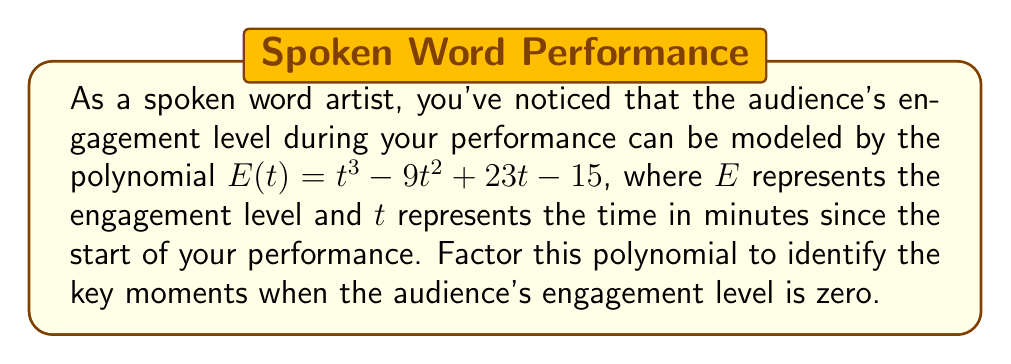Can you answer this question? To factor this cubic polynomial, we'll follow these steps:

1) First, let's check if there's a rational root. We can use the rational root theorem to find potential roots. The factors of the constant term (15) are ±1, ±3, ±5, ±15.

2) Testing these values, we find that $t = 1$ is a root of the polynomial.

3) We can factor out $(t - 1)$:

   $E(t) = (t - 1)(t^2 + at + b)$

4) Expanding this:

   $t^3 + at^2 + bt - t^2 - at - b = t^3 - 9t^2 + 23t - 15$

5) Comparing coefficients:

   $a - 1 = -9$, so $a = -8$
   $b - a = 23$, so $b = 31$
   $-b = -15$, which confirms $b = 15$

6) Our factored polynomial is now:

   $E(t) = (t - 1)(t^2 - 8t + 15)$

7) The quadratic factor can be further factored:

   $t^2 - 8t + 15 = (t - 3)(t - 5)$

8) Therefore, the fully factored polynomial is:

   $E(t) = (t - 1)(t - 3)(t - 5)$

This factorization reveals that the audience's engagement level reaches zero at 1, 3, and 5 minutes into the performance.
Answer: $E(t) = (t - 1)(t - 3)(t - 5)$ 